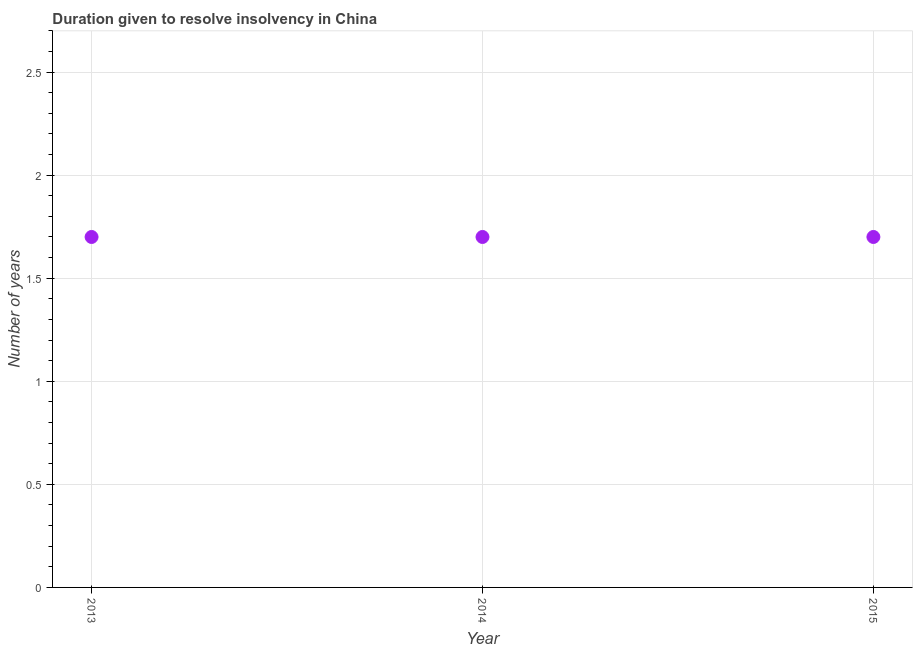Across all years, what is the maximum number of years to resolve insolvency?
Keep it short and to the point. 1.7. Across all years, what is the minimum number of years to resolve insolvency?
Provide a short and direct response. 1.7. In which year was the number of years to resolve insolvency minimum?
Your answer should be very brief. 2013. What is the sum of the number of years to resolve insolvency?
Your response must be concise. 5.1. What is the difference between the number of years to resolve insolvency in 2013 and 2014?
Provide a succinct answer. 0. What is the median number of years to resolve insolvency?
Your answer should be very brief. 1.7. In how many years, is the number of years to resolve insolvency greater than 1.5 ?
Give a very brief answer. 3. What is the ratio of the number of years to resolve insolvency in 2013 to that in 2014?
Your answer should be very brief. 1. Is the number of years to resolve insolvency in 2014 less than that in 2015?
Your answer should be compact. No. Is the sum of the number of years to resolve insolvency in 2014 and 2015 greater than the maximum number of years to resolve insolvency across all years?
Offer a terse response. Yes. What is the difference between the highest and the lowest number of years to resolve insolvency?
Keep it short and to the point. 0. Does the number of years to resolve insolvency monotonically increase over the years?
Give a very brief answer. No. How many years are there in the graph?
Give a very brief answer. 3. What is the difference between two consecutive major ticks on the Y-axis?
Your answer should be very brief. 0.5. Does the graph contain grids?
Your answer should be compact. Yes. What is the title of the graph?
Give a very brief answer. Duration given to resolve insolvency in China. What is the label or title of the Y-axis?
Provide a succinct answer. Number of years. What is the Number of years in 2013?
Offer a very short reply. 1.7. What is the Number of years in 2014?
Your response must be concise. 1.7. What is the difference between the Number of years in 2013 and 2014?
Provide a succinct answer. 0. What is the ratio of the Number of years in 2013 to that in 2014?
Your answer should be compact. 1. What is the ratio of the Number of years in 2013 to that in 2015?
Your answer should be compact. 1. 